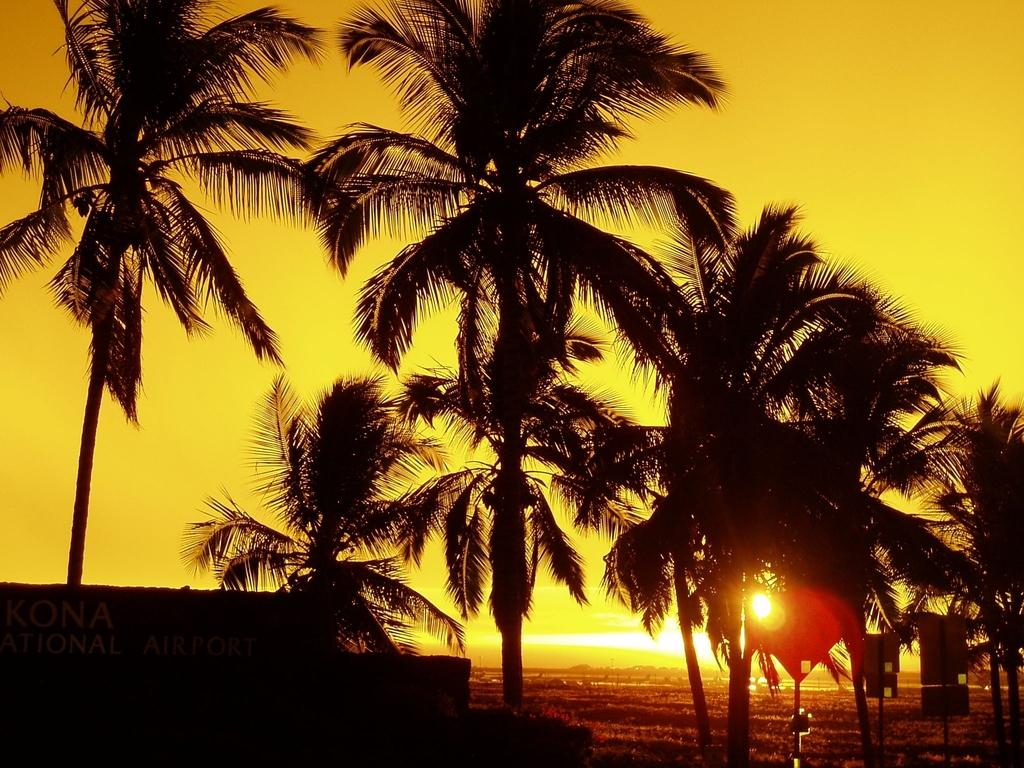What type of trees can be seen in the image? There are many coconut trees in the image. What natural phenomenon is visible in the image? A sunrise is clearly visible in the image. How is the sunrise visible in the image? The sunrise is visible through one of the coconut trees. What type of bath can be seen hanging from one of the coconut trees in the image? There is no bath present in the image; it features coconut trees and a sunrise. 